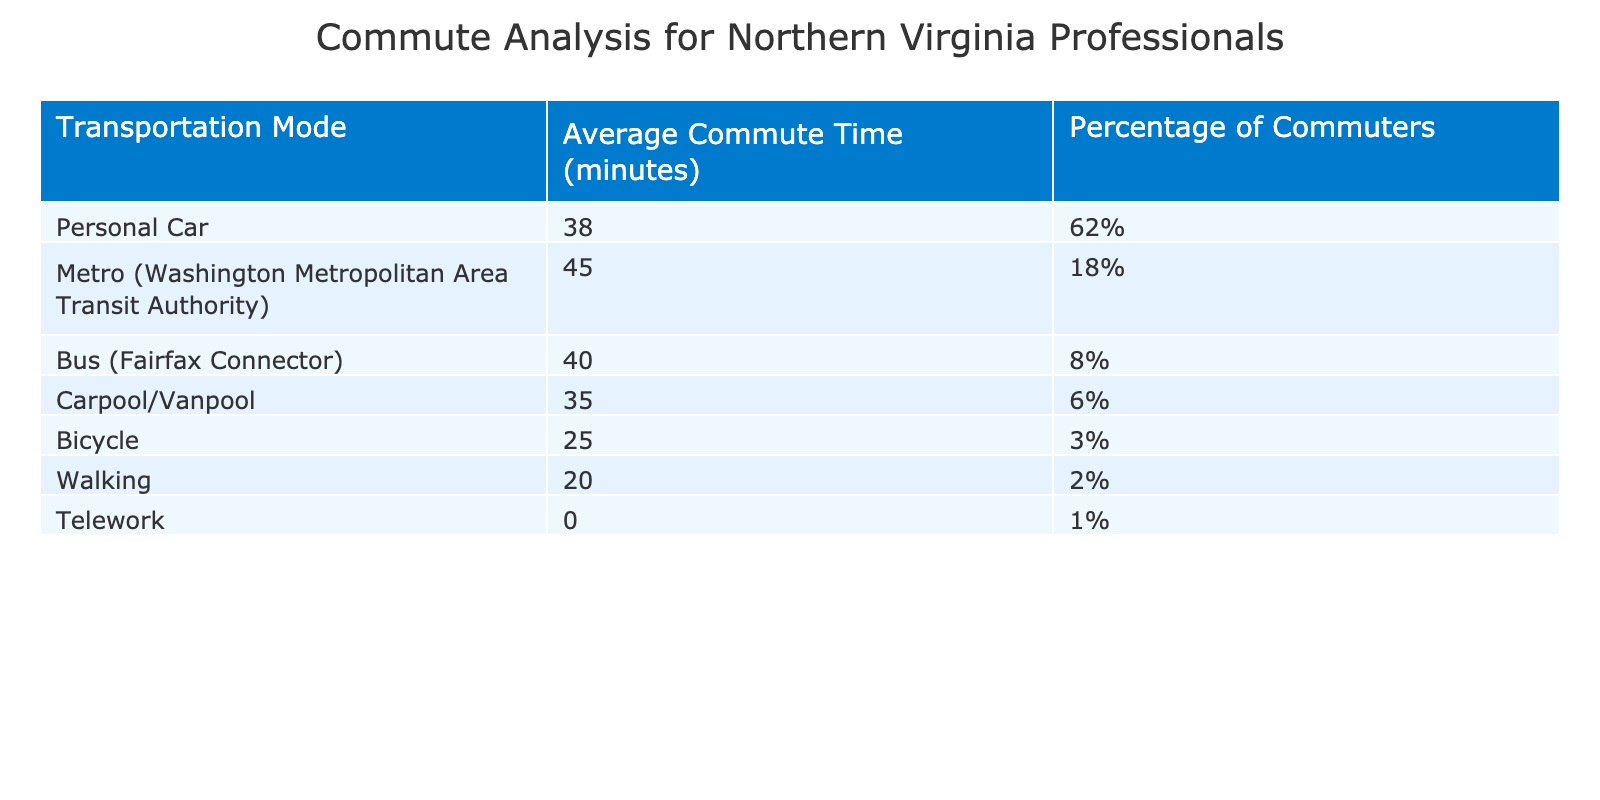What is the average commute time for those who use a personal car? The average commute time for users of a personal car is listed directly in the table, which shows it to be 38 minutes.
Answer: 38 minutes What percentage of commuters in Northern Virginia use buses for their commute? The percentage of commuters using buses is directly provided in the table, which indicates that 8% of commuters use the Fairfax Connector bus service.
Answer: 8% Which transportation mode has the shortest average commute time? The table shows that the bicycle has the shortest average commute time of 25 minutes, as this is the lowest value in the 'Average Commute Time' column.
Answer: Bicycle What is the difference in average commute time between using the Metro and walking? The average commute time for the Metro is 45 minutes and for walking, it is 20 minutes. The difference is 45 minutes - 20 minutes = 25 minutes.
Answer: 25 minutes How many more minutes does the average bus commute take compared to cycling? The average commute time for the bus is 40 minutes and for cycling, it is 25 minutes. The difference is 40 - 25 = 15 minutes more for the bus.
Answer: 15 minutes What percentage of commuters telework? The table clearly states that only 1% of commuters telework, as listed in the 'Percentage of Commuters' column.
Answer: 1% If a commuter chooses to carpool instead of driving a personal car, how much time do they save on average? The average commute time for a carpool is 35 minutes and for a personal car is 38 minutes. The time saved is 38 minutes - 35 minutes = 3 minutes.
Answer: 3 minutes Is it true that more than half of the commuters use personal cars? The percentage of commuters using personal cars is 62%, which is indeed more than half, confirming that the statement is true.
Answer: True What is the combined percentage of commuters using Metro and bus services? The percentage of Metro users is 18% and bus users is 8%. Their combined percentage is 18% + 8% = 26%.
Answer: 26% Which transportation mode is used the least among commuters in Northern Virginia? The table shows that walking has the lowest percentage at 2%, indicating that it is the least used transportation mode.
Answer: Walking 